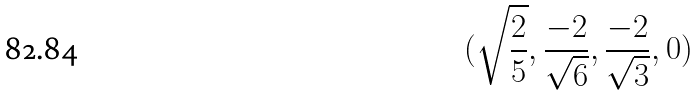<formula> <loc_0><loc_0><loc_500><loc_500>( \sqrt { \frac { 2 } { 5 } } , \frac { - 2 } { \sqrt { 6 } } , \frac { - 2 } { \sqrt { 3 } } , 0 )</formula> 